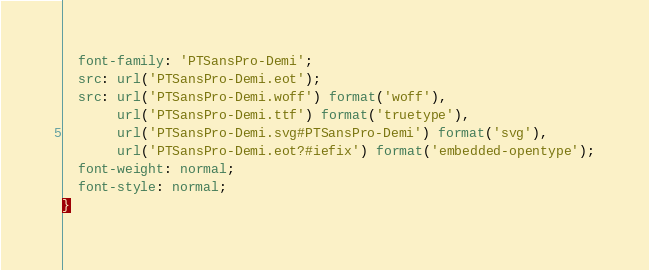<code> <loc_0><loc_0><loc_500><loc_500><_CSS_>  font-family: 'PTSansPro-Demi';
  src: url('PTSansPro-Demi.eot');
  src: url('PTSansPro-Demi.woff') format('woff'),
       url('PTSansPro-Demi.ttf') format('truetype'),
       url('PTSansPro-Demi.svg#PTSansPro-Demi') format('svg'),
       url('PTSansPro-Demi.eot?#iefix') format('embedded-opentype');
  font-weight: normal;
  font-style: normal;
}</code> 